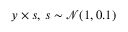Convert formula to latex. <formula><loc_0><loc_0><loc_500><loc_500>y \times s , \, s \sim \mathcal { N } ( 1 , 0 . 1 )</formula> 